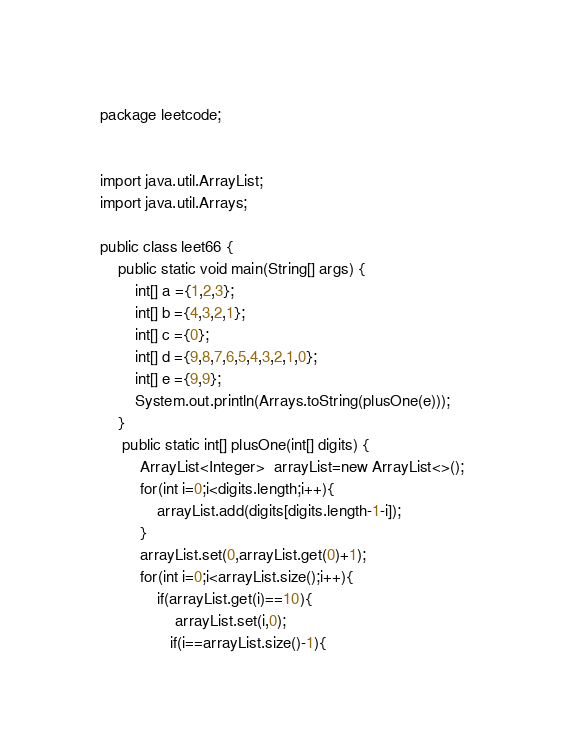Convert code to text. <code><loc_0><loc_0><loc_500><loc_500><_Java_>package leetcode;


import java.util.ArrayList;
import java.util.Arrays;

public class leet66 {
    public static void main(String[] args) {
        int[] a ={1,2,3};
        int[] b ={4,3,2,1};
        int[] c ={0};
        int[] d ={9,8,7,6,5,4,3,2,1,0};
        int[] e ={9,9};
        System.out.println(Arrays.toString(plusOne(e)));
    }
     public static int[] plusOne(int[] digits) {
         ArrayList<Integer>  arrayList=new ArrayList<>();
         for(int i=0;i<digits.length;i++){
             arrayList.add(digits[digits.length-1-i]);
         }
         arrayList.set(0,arrayList.get(0)+1);
         for(int i=0;i<arrayList.size();i++){
             if(arrayList.get(i)==10){
                 arrayList.set(i,0);
                if(i==arrayList.size()-1){</code> 